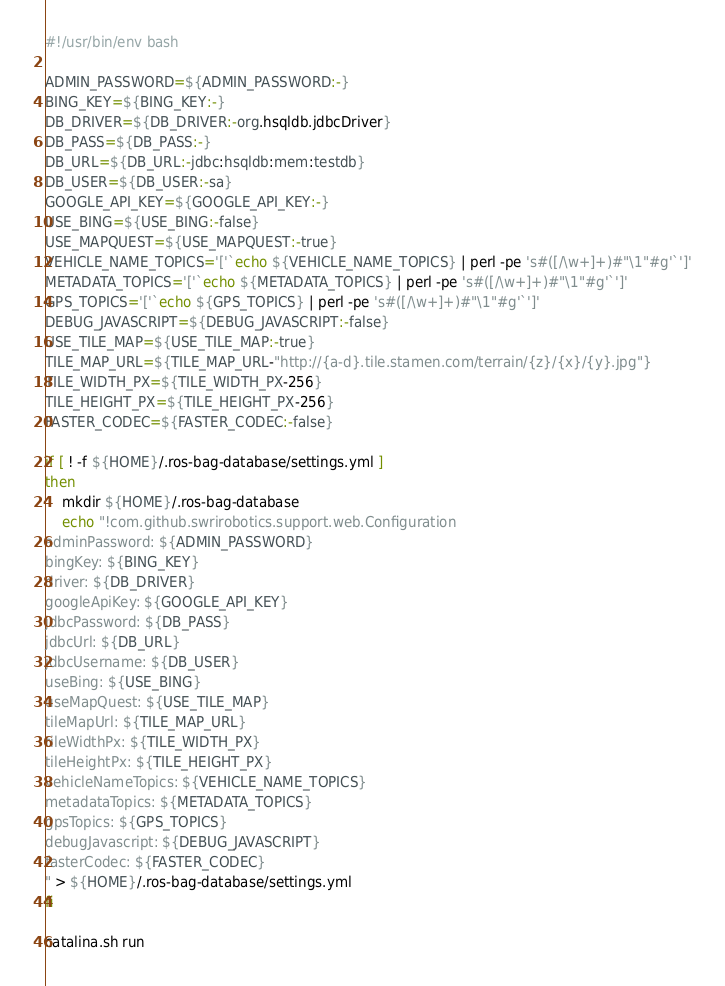Convert code to text. <code><loc_0><loc_0><loc_500><loc_500><_Bash_>#!/usr/bin/env bash

ADMIN_PASSWORD=${ADMIN_PASSWORD:-}
BING_KEY=${BING_KEY:-}
DB_DRIVER=${DB_DRIVER:-org.hsqldb.jdbcDriver}
DB_PASS=${DB_PASS:-}
DB_URL=${DB_URL:-jdbc:hsqldb:mem:testdb}
DB_USER=${DB_USER:-sa}
GOOGLE_API_KEY=${GOOGLE_API_KEY:-}
USE_BING=${USE_BING:-false}
USE_MAPQUEST=${USE_MAPQUEST:-true}
VEHICLE_NAME_TOPICS='['`echo ${VEHICLE_NAME_TOPICS} | perl -pe 's#([/\w+]+)#"\1"#g'`']'
METADATA_TOPICS='['`echo ${METADATA_TOPICS} | perl -pe 's#([/\w+]+)#"\1"#g'`']'
GPS_TOPICS='['`echo ${GPS_TOPICS} | perl -pe 's#([/\w+]+)#"\1"#g'`']'
DEBUG_JAVASCRIPT=${DEBUG_JAVASCRIPT:-false}
USE_TILE_MAP=${USE_TILE_MAP:-true}
TILE_MAP_URL=${TILE_MAP_URL-"http://{a-d}.tile.stamen.com/terrain/{z}/{x}/{y}.jpg"}
TILE_WIDTH_PX=${TILE_WIDTH_PX-256}
TILE_HEIGHT_PX=${TILE_HEIGHT_PX-256}
FASTER_CODEC=${FASTER_CODEC:-false}

if [ ! -f ${HOME}/.ros-bag-database/settings.yml ]
then
    mkdir ${HOME}/.ros-bag-database
    echo "!com.github.swrirobotics.support.web.Configuration
adminPassword: ${ADMIN_PASSWORD}
bingKey: ${BING_KEY}
driver: ${DB_DRIVER}
googleApiKey: ${GOOGLE_API_KEY}
jdbcPassword: ${DB_PASS}
jdbcUrl: ${DB_URL}
jdbcUsername: ${DB_USER}
useBing: ${USE_BING}
useMapQuest: ${USE_TILE_MAP}
tileMapUrl: ${TILE_MAP_URL}
tileWidthPx: ${TILE_WIDTH_PX}
tileHeightPx: ${TILE_HEIGHT_PX}
vehicleNameTopics: ${VEHICLE_NAME_TOPICS}
metadataTopics: ${METADATA_TOPICS}
gpsTopics: ${GPS_TOPICS}
debugJavascript: ${DEBUG_JAVASCRIPT}
fasterCodec: ${FASTER_CODEC}
" > ${HOME}/.ros-bag-database/settings.yml
fi

catalina.sh run
</code> 